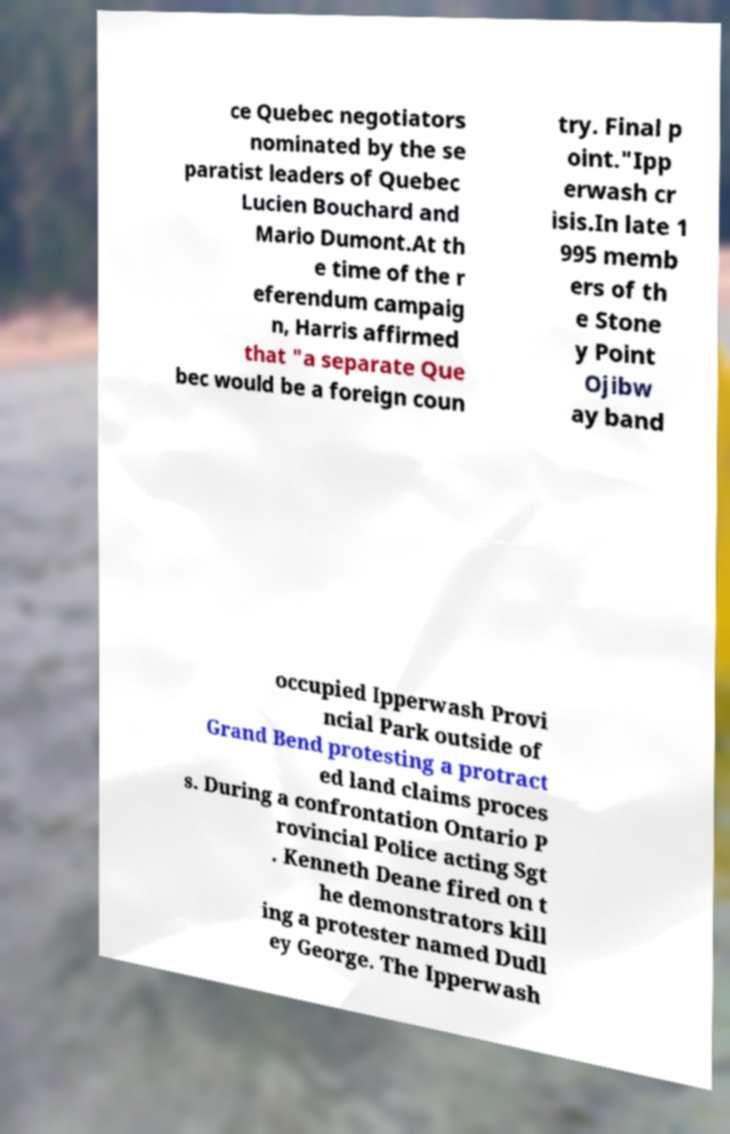Can you accurately transcribe the text from the provided image for me? ce Quebec negotiators nominated by the se paratist leaders of Quebec Lucien Bouchard and Mario Dumont.At th e time of the r eferendum campaig n, Harris affirmed that "a separate Que bec would be a foreign coun try. Final p oint."Ipp erwash cr isis.In late 1 995 memb ers of th e Stone y Point Ojibw ay band occupied Ipperwash Provi ncial Park outside of Grand Bend protesting a protract ed land claims proces s. During a confrontation Ontario P rovincial Police acting Sgt . Kenneth Deane fired on t he demonstrators kill ing a protester named Dudl ey George. The Ipperwash 